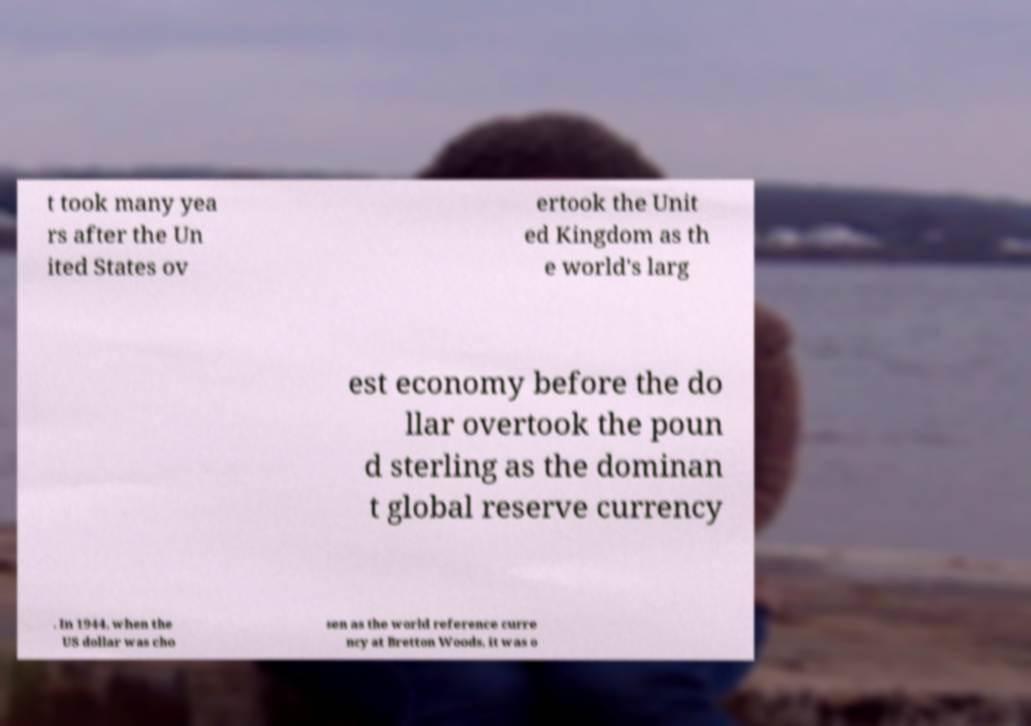Can you accurately transcribe the text from the provided image for me? t took many yea rs after the Un ited States ov ertook the Unit ed Kingdom as th e world's larg est economy before the do llar overtook the poun d sterling as the dominan t global reserve currency . In 1944, when the US dollar was cho sen as the world reference curre ncy at Bretton Woods, it was o 